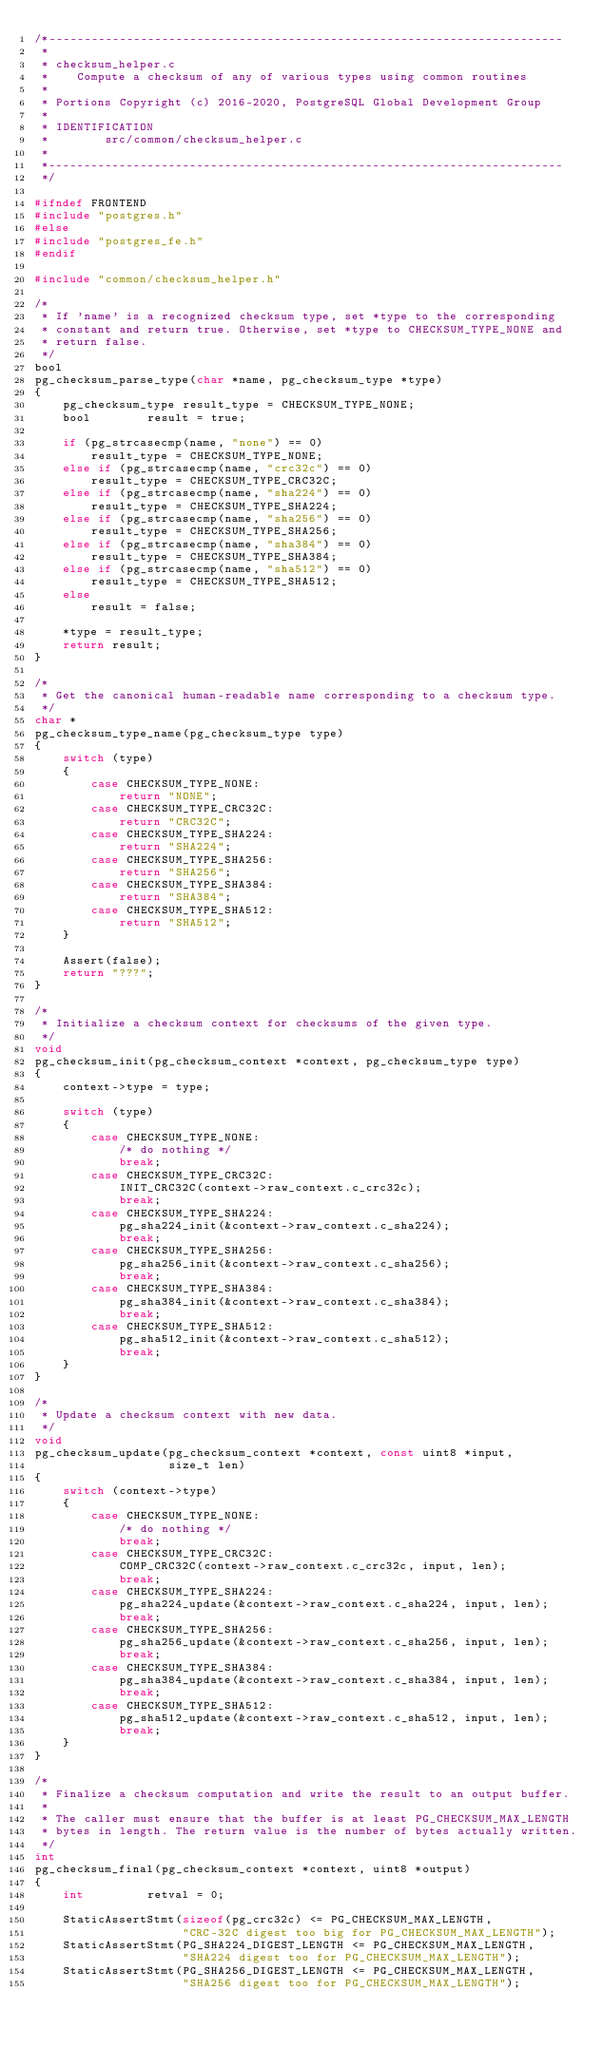Convert code to text. <code><loc_0><loc_0><loc_500><loc_500><_C_>/*-------------------------------------------------------------------------
 *
 * checksum_helper.c
 *	  Compute a checksum of any of various types using common routines
 *
 * Portions Copyright (c) 2016-2020, PostgreSQL Global Development Group
 *
 * IDENTIFICATION
 *		  src/common/checksum_helper.c
 *
 *-------------------------------------------------------------------------
 */

#ifndef FRONTEND
#include "postgres.h"
#else
#include "postgres_fe.h"
#endif

#include "common/checksum_helper.h"

/*
 * If 'name' is a recognized checksum type, set *type to the corresponding
 * constant and return true. Otherwise, set *type to CHECKSUM_TYPE_NONE and
 * return false.
 */
bool
pg_checksum_parse_type(char *name, pg_checksum_type *type)
{
	pg_checksum_type result_type = CHECKSUM_TYPE_NONE;
	bool		result = true;

	if (pg_strcasecmp(name, "none") == 0)
		result_type = CHECKSUM_TYPE_NONE;
	else if (pg_strcasecmp(name, "crc32c") == 0)
		result_type = CHECKSUM_TYPE_CRC32C;
	else if (pg_strcasecmp(name, "sha224") == 0)
		result_type = CHECKSUM_TYPE_SHA224;
	else if (pg_strcasecmp(name, "sha256") == 0)
		result_type = CHECKSUM_TYPE_SHA256;
	else if (pg_strcasecmp(name, "sha384") == 0)
		result_type = CHECKSUM_TYPE_SHA384;
	else if (pg_strcasecmp(name, "sha512") == 0)
		result_type = CHECKSUM_TYPE_SHA512;
	else
		result = false;

	*type = result_type;
	return result;
}

/*
 * Get the canonical human-readable name corresponding to a checksum type.
 */
char *
pg_checksum_type_name(pg_checksum_type type)
{
	switch (type)
	{
		case CHECKSUM_TYPE_NONE:
			return "NONE";
		case CHECKSUM_TYPE_CRC32C:
			return "CRC32C";
		case CHECKSUM_TYPE_SHA224:
			return "SHA224";
		case CHECKSUM_TYPE_SHA256:
			return "SHA256";
		case CHECKSUM_TYPE_SHA384:
			return "SHA384";
		case CHECKSUM_TYPE_SHA512:
			return "SHA512";
	}

	Assert(false);
	return "???";
}

/*
 * Initialize a checksum context for checksums of the given type.
 */
void
pg_checksum_init(pg_checksum_context *context, pg_checksum_type type)
{
	context->type = type;

	switch (type)
	{
		case CHECKSUM_TYPE_NONE:
			/* do nothing */
			break;
		case CHECKSUM_TYPE_CRC32C:
			INIT_CRC32C(context->raw_context.c_crc32c);
			break;
		case CHECKSUM_TYPE_SHA224:
			pg_sha224_init(&context->raw_context.c_sha224);
			break;
		case CHECKSUM_TYPE_SHA256:
			pg_sha256_init(&context->raw_context.c_sha256);
			break;
		case CHECKSUM_TYPE_SHA384:
			pg_sha384_init(&context->raw_context.c_sha384);
			break;
		case CHECKSUM_TYPE_SHA512:
			pg_sha512_init(&context->raw_context.c_sha512);
			break;
	}
}

/*
 * Update a checksum context with new data.
 */
void
pg_checksum_update(pg_checksum_context *context, const uint8 *input,
				   size_t len)
{
	switch (context->type)
	{
		case CHECKSUM_TYPE_NONE:
			/* do nothing */
			break;
		case CHECKSUM_TYPE_CRC32C:
			COMP_CRC32C(context->raw_context.c_crc32c, input, len);
			break;
		case CHECKSUM_TYPE_SHA224:
			pg_sha224_update(&context->raw_context.c_sha224, input, len);
			break;
		case CHECKSUM_TYPE_SHA256:
			pg_sha256_update(&context->raw_context.c_sha256, input, len);
			break;
		case CHECKSUM_TYPE_SHA384:
			pg_sha384_update(&context->raw_context.c_sha384, input, len);
			break;
		case CHECKSUM_TYPE_SHA512:
			pg_sha512_update(&context->raw_context.c_sha512, input, len);
			break;
	}
}

/*
 * Finalize a checksum computation and write the result to an output buffer.
 *
 * The caller must ensure that the buffer is at least PG_CHECKSUM_MAX_LENGTH
 * bytes in length. The return value is the number of bytes actually written.
 */
int
pg_checksum_final(pg_checksum_context *context, uint8 *output)
{
	int			retval = 0;

	StaticAssertStmt(sizeof(pg_crc32c) <= PG_CHECKSUM_MAX_LENGTH,
					 "CRC-32C digest too big for PG_CHECKSUM_MAX_LENGTH");
	StaticAssertStmt(PG_SHA224_DIGEST_LENGTH <= PG_CHECKSUM_MAX_LENGTH,
					 "SHA224 digest too for PG_CHECKSUM_MAX_LENGTH");
	StaticAssertStmt(PG_SHA256_DIGEST_LENGTH <= PG_CHECKSUM_MAX_LENGTH,
					 "SHA256 digest too for PG_CHECKSUM_MAX_LENGTH");</code> 